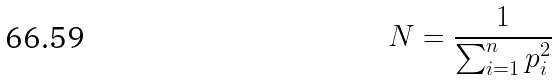Convert formula to latex. <formula><loc_0><loc_0><loc_500><loc_500>N = \frac { 1 } { \sum _ { i = 1 } ^ { n } p _ { i } ^ { 2 } }</formula> 